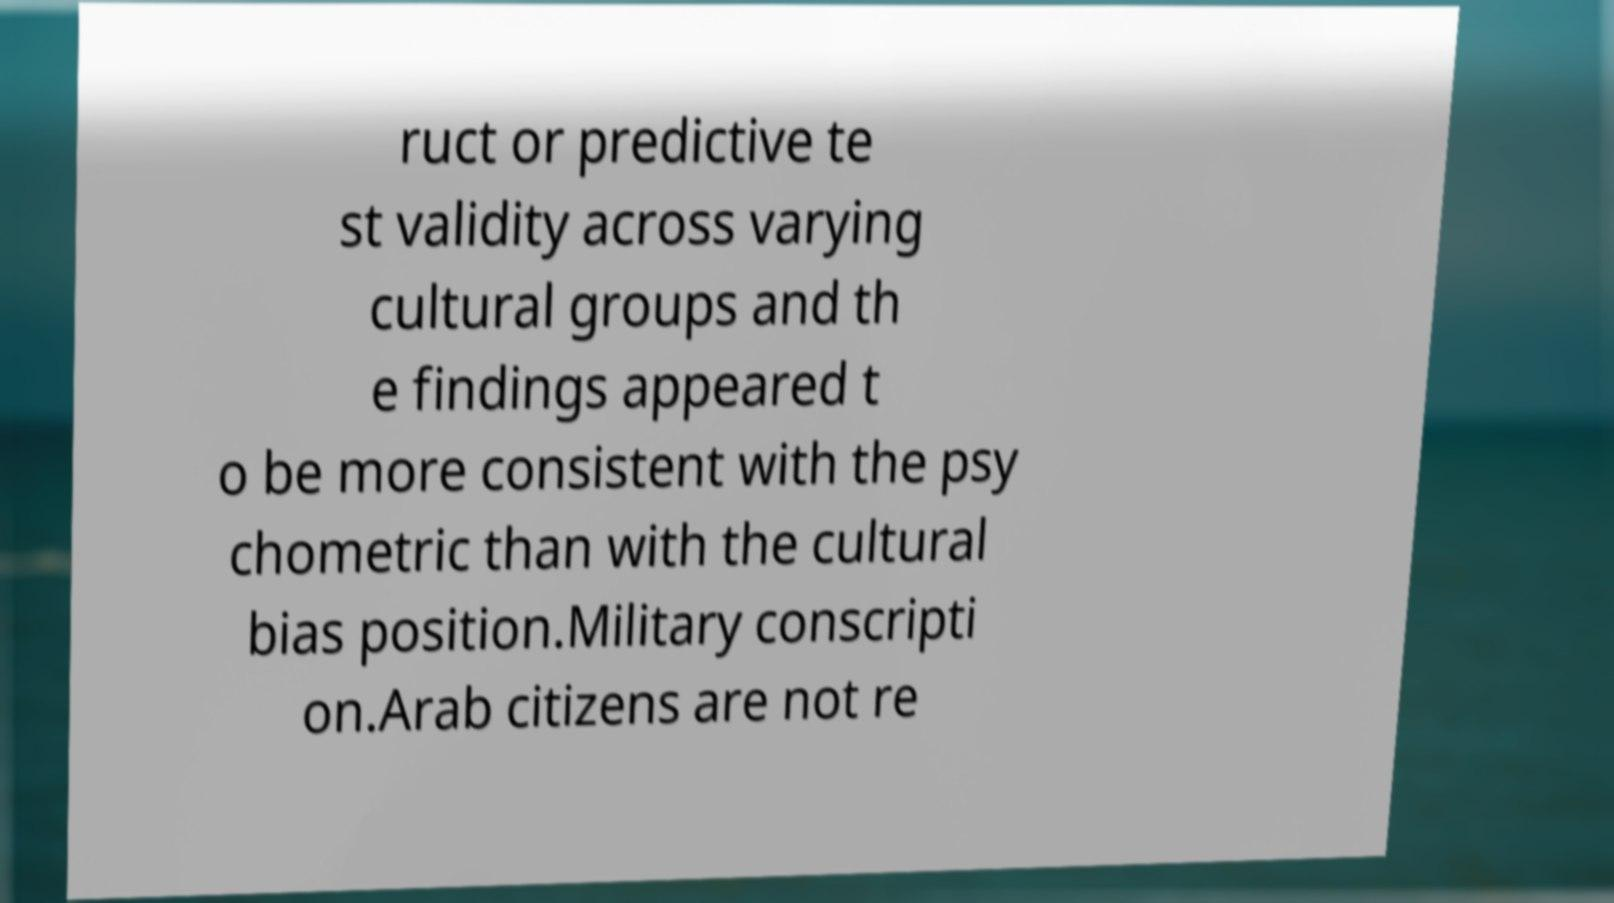What messages or text are displayed in this image? I need them in a readable, typed format. ruct or predictive te st validity across varying cultural groups and th e findings appeared t o be more consistent with the psy chometric than with the cultural bias position.Military conscripti on.Arab citizens are not re 